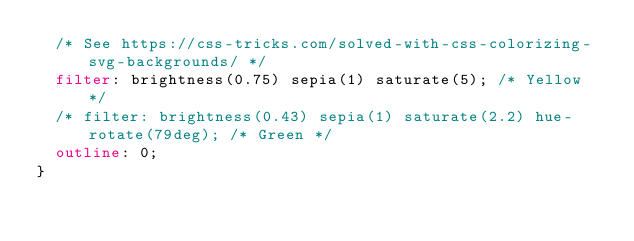Convert code to text. <code><loc_0><loc_0><loc_500><loc_500><_CSS_>	/* See https://css-tricks.com/solved-with-css-colorizing-svg-backgrounds/ */
	filter: brightness(0.75) sepia(1) saturate(5); /* Yellow */
	/* filter: brightness(0.43) sepia(1) saturate(2.2) hue-rotate(79deg); /* Green */
	outline: 0;
}</code> 